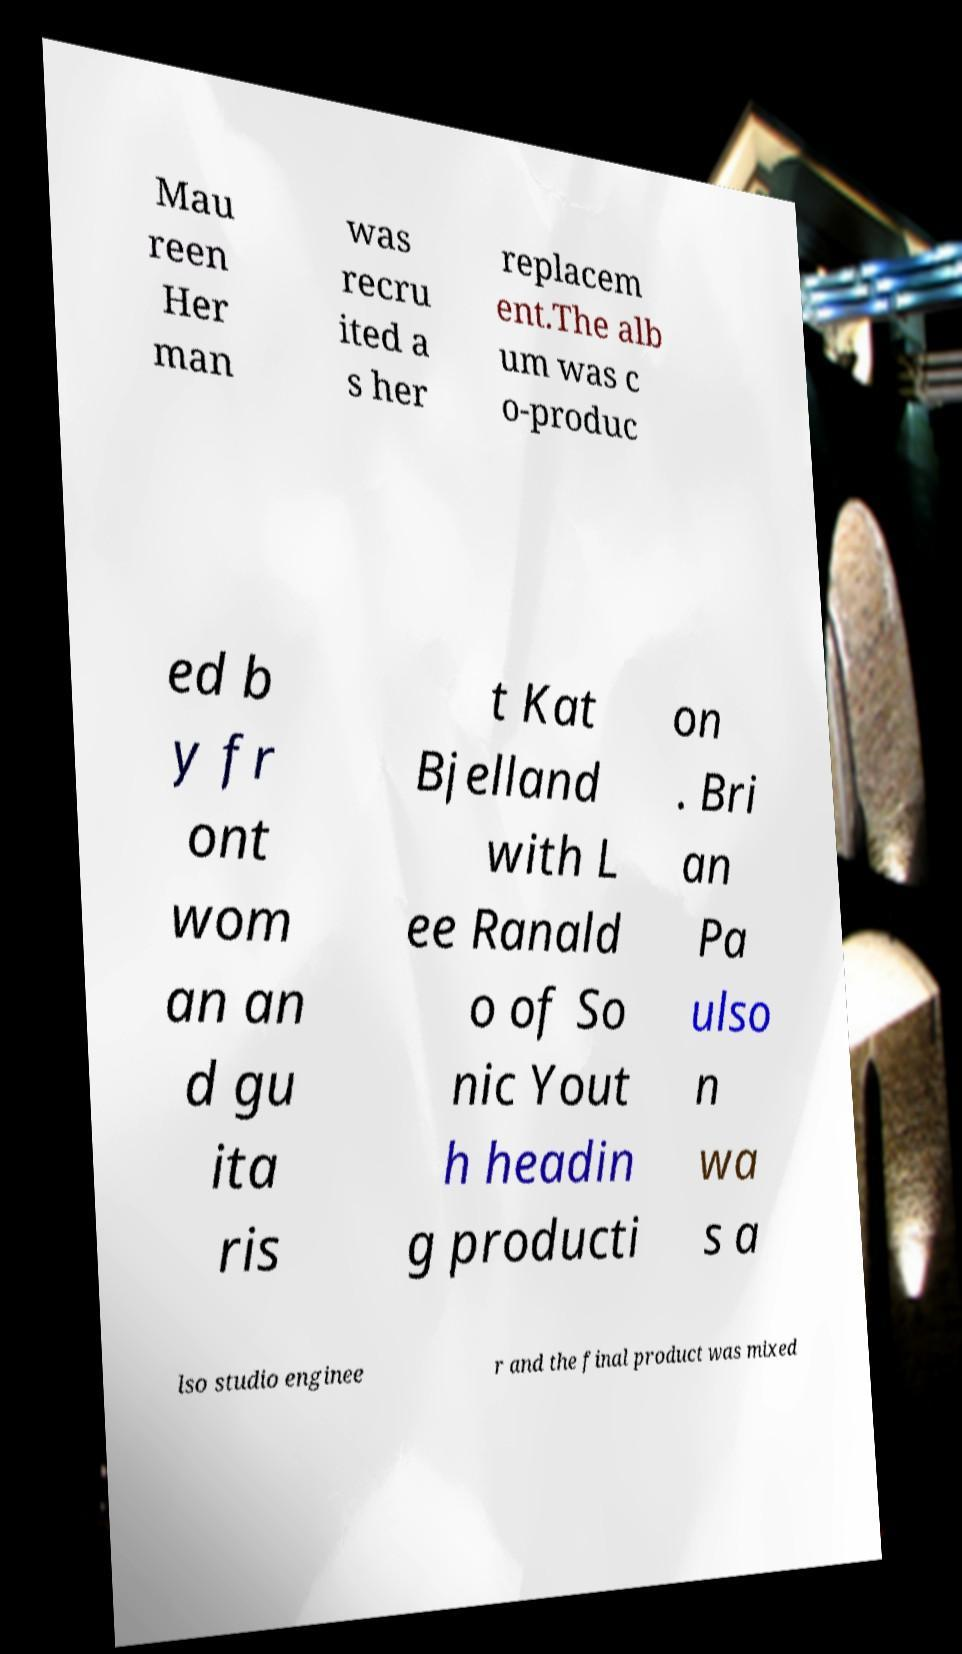For documentation purposes, I need the text within this image transcribed. Could you provide that? Mau reen Her man was recru ited a s her replacem ent.The alb um was c o-produc ed b y fr ont wom an an d gu ita ris t Kat Bjelland with L ee Ranald o of So nic Yout h headin g producti on . Bri an Pa ulso n wa s a lso studio enginee r and the final product was mixed 